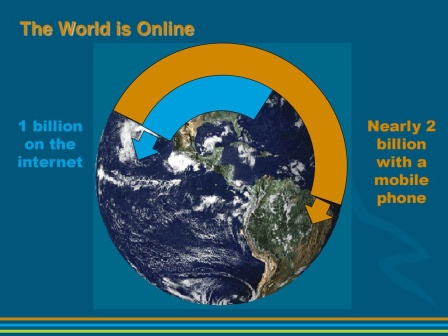What do you think is going on in this snapshot? The image presents a vibrant depiction of the digital age. Dominating the center is a graphic representation of the world, bathed in hues of blue and green. An orange arch gracefully spans over the globe, symbolizing the connectivity of our world.

On the left side of the arch, an arrow points towards the world, carrying the message "1 billion on the internet". This signifies the vast number of internet users globally. On the right side, another arrow echoes a similar sentiment, stating "Nearly 2 billion with a mobile phone". This highlights the prevalence of mobile technology in our lives.

The backdrop is a soothing blue, perhaps symbolizing the vastness of the digital space. Floating above the globe is the phrase "The World is Online", a testament to the interconnectedness of our modern world. The image encapsulates the essence of our digital era, where billions are connected through the internet and mobile technology. 